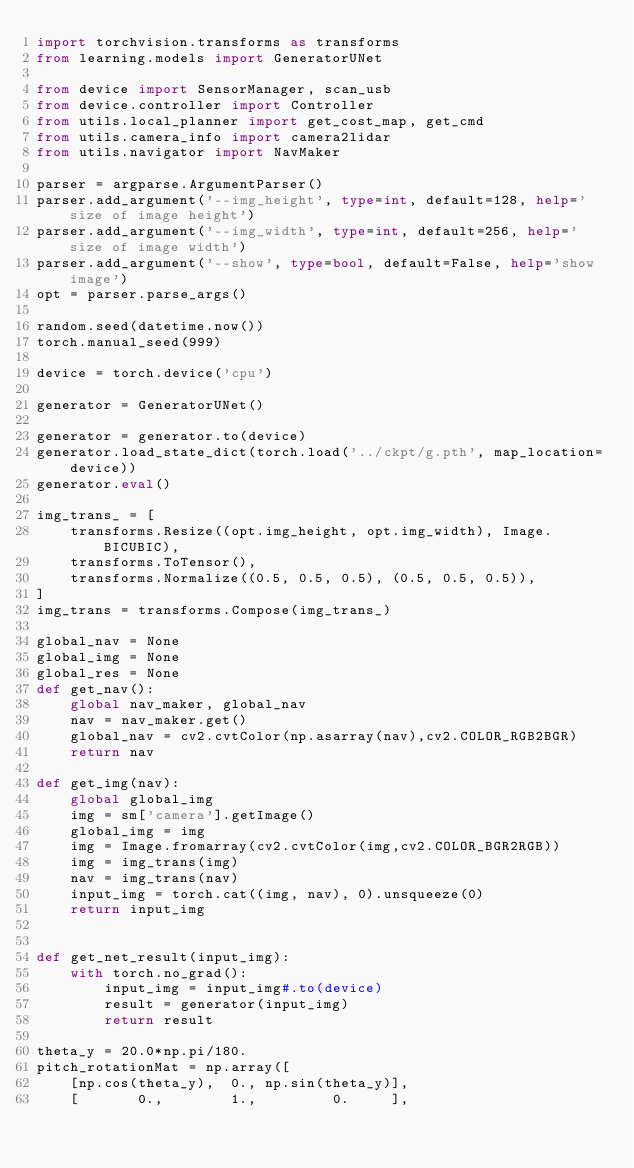Convert code to text. <code><loc_0><loc_0><loc_500><loc_500><_Python_>import torchvision.transforms as transforms
from learning.models import GeneratorUNet

from device import SensorManager, scan_usb
from device.controller import Controller
from utils.local_planner import get_cost_map, get_cmd
from utils.camera_info import camera2lidar
from utils.navigator import NavMaker

parser = argparse.ArgumentParser()
parser.add_argument('--img_height', type=int, default=128, help='size of image height')
parser.add_argument('--img_width', type=int, default=256, help='size of image width')
parser.add_argument('--show', type=bool, default=False, help='show image')
opt = parser.parse_args()

random.seed(datetime.now())
torch.manual_seed(999)

device = torch.device('cpu')

generator = GeneratorUNet()

generator = generator.to(device)
generator.load_state_dict(torch.load('../ckpt/g.pth', map_location=device))
generator.eval()

img_trans_ = [
    transforms.Resize((opt.img_height, opt.img_width), Image.BICUBIC),
    transforms.ToTensor(),
    transforms.Normalize((0.5, 0.5, 0.5), (0.5, 0.5, 0.5)),
]
img_trans = transforms.Compose(img_trans_)

global_nav = None
global_img = None
global_res = None
def get_nav():
    global nav_maker, global_nav
    nav = nav_maker.get()
    global_nav = cv2.cvtColor(np.asarray(nav),cv2.COLOR_RGB2BGR) 
    return nav

def get_img(nav):
    global global_img
    img = sm['camera'].getImage()
    global_img = img
    img = Image.fromarray(cv2.cvtColor(img,cv2.COLOR_BGR2RGB))
    img = img_trans(img)
    nav = img_trans(nav)
    input_img = torch.cat((img, nav), 0).unsqueeze(0)
    return input_img
    

def get_net_result(input_img):
    with torch.no_grad():
        input_img = input_img#.to(device)
        result = generator(input_img)
        return result

theta_y = 20.0*np.pi/180.
pitch_rotationMat = np.array([
    [np.cos(theta_y),  0., np.sin(theta_y)],
    [       0.,        1.,         0.     ],</code> 